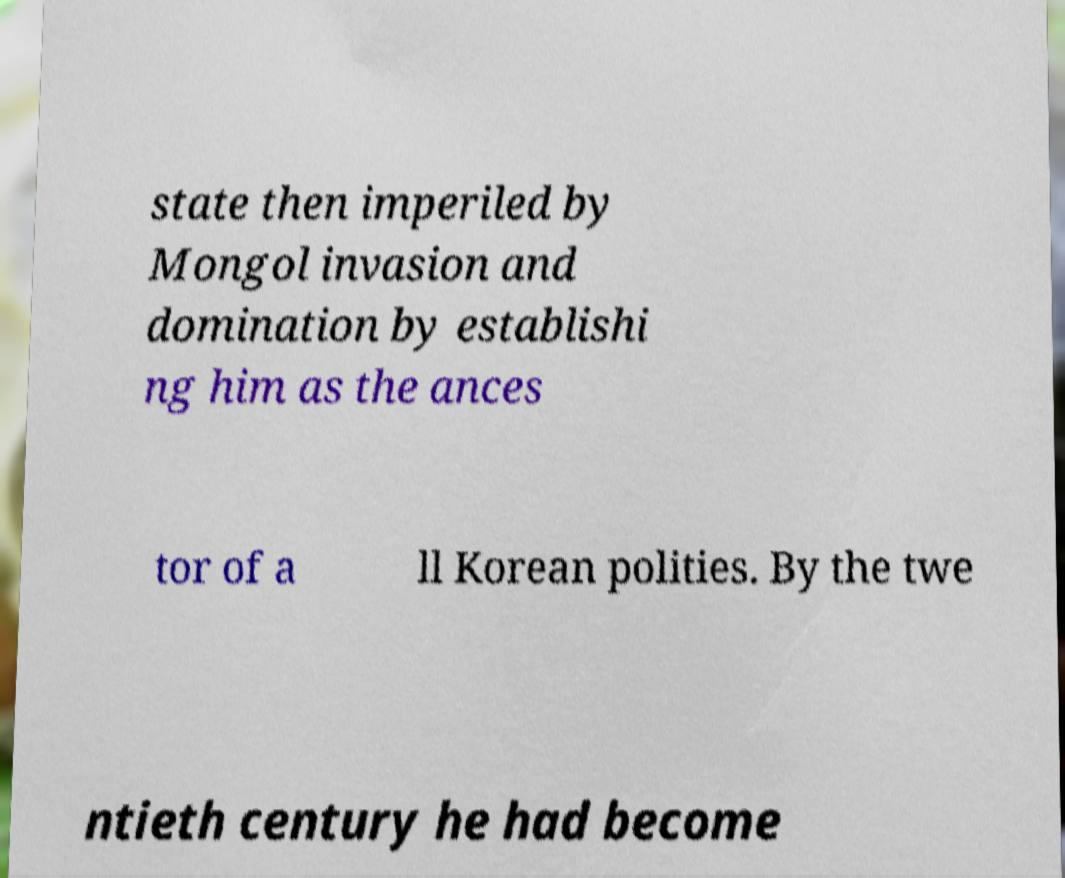Could you assist in decoding the text presented in this image and type it out clearly? state then imperiled by Mongol invasion and domination by establishi ng him as the ances tor of a ll Korean polities. By the twe ntieth century he had become 